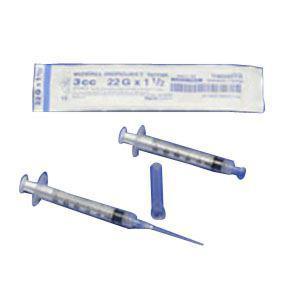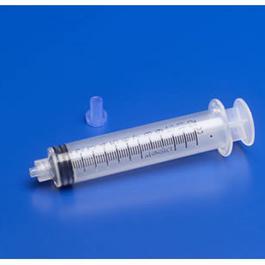The first image is the image on the left, the second image is the image on the right. Assess this claim about the two images: "The combined images include a white wrapper and an upright blue lid behind a syringe with an exposed tip.". Correct or not? Answer yes or no. Yes. The first image is the image on the left, the second image is the image on the right. Given the left and right images, does the statement "A blue cap is next to at least 1 syringe with a needle." hold true? Answer yes or no. Yes. 